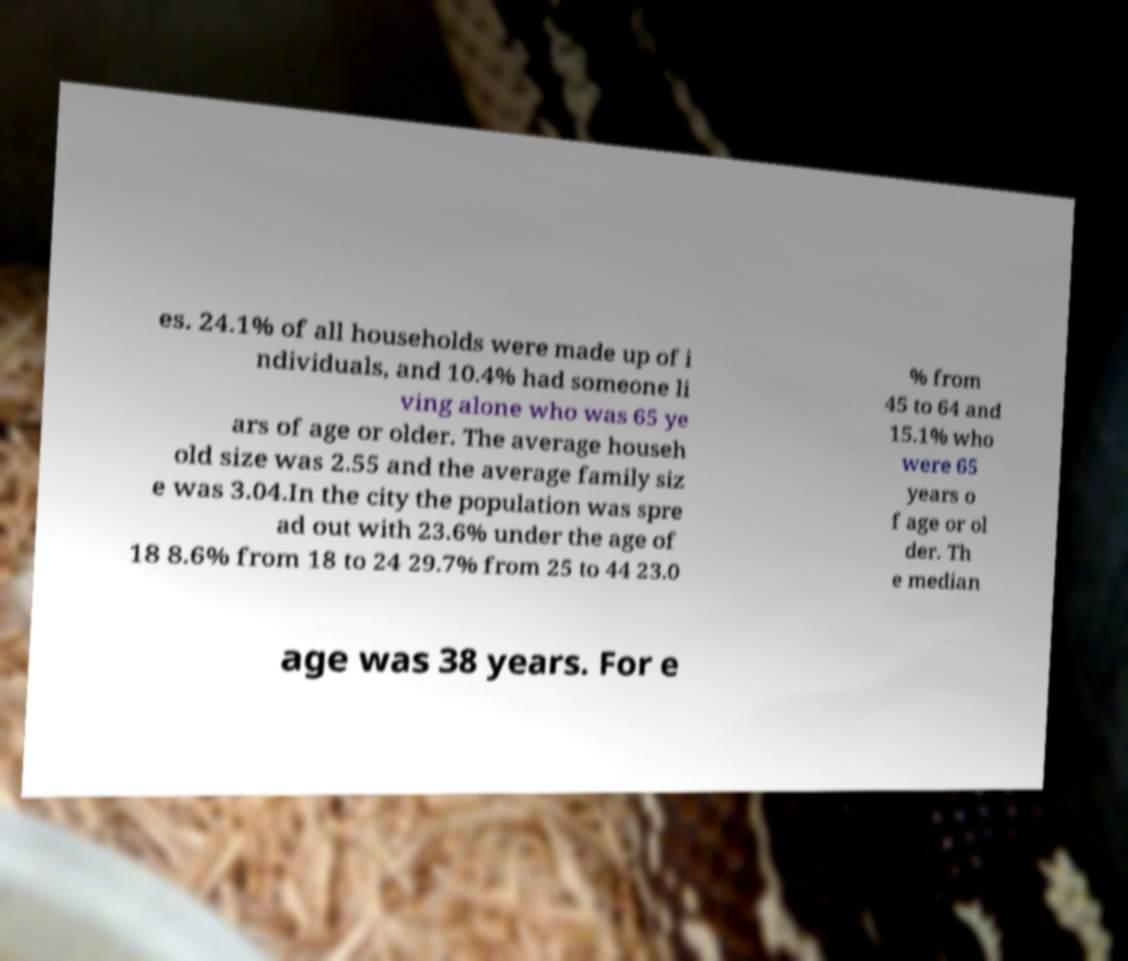Can you read and provide the text displayed in the image?This photo seems to have some interesting text. Can you extract and type it out for me? es. 24.1% of all households were made up of i ndividuals, and 10.4% had someone li ving alone who was 65 ye ars of age or older. The average househ old size was 2.55 and the average family siz e was 3.04.In the city the population was spre ad out with 23.6% under the age of 18 8.6% from 18 to 24 29.7% from 25 to 44 23.0 % from 45 to 64 and 15.1% who were 65 years o f age or ol der. Th e median age was 38 years. For e 